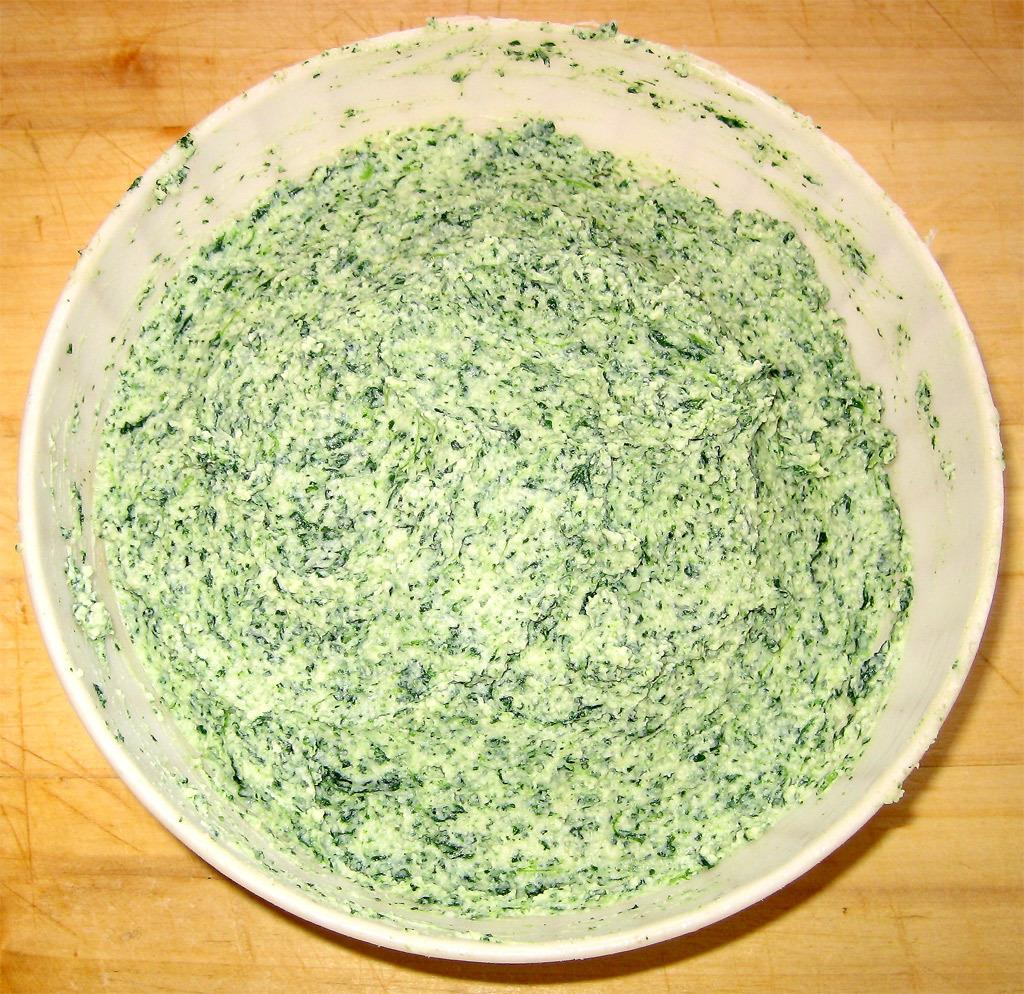What is in the bowl that is visible in the image? There is food in the bowl in the image. What can be said about the color of the food in the bowl? The food is green in color. On what surface is the bowl placed in the image? The bowl is on a brown surface. How many ducks are swimming in the bowl in the image? There are no ducks present in the image; it features a bowl of green food on a brown surface. 